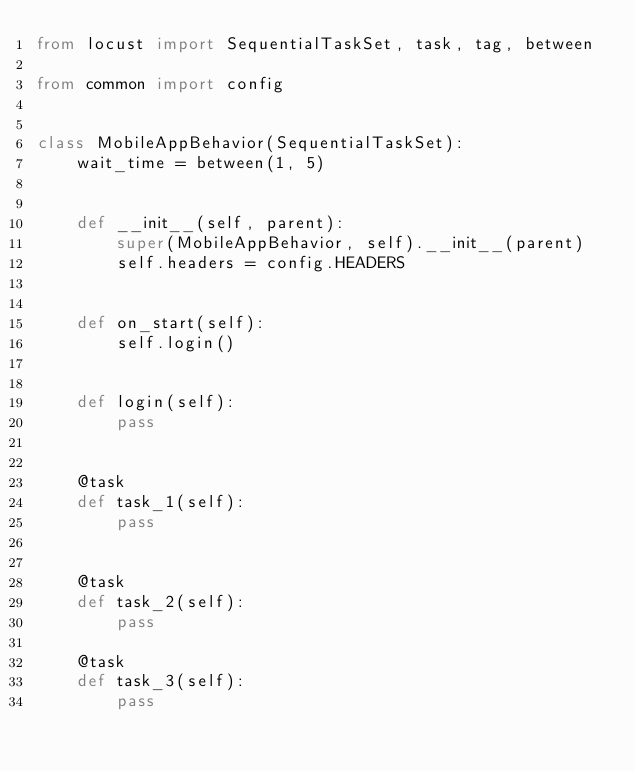<code> <loc_0><loc_0><loc_500><loc_500><_Python_>from locust import SequentialTaskSet, task, tag, between

from common import config


class MobileAppBehavior(SequentialTaskSet):
	wait_time = between(1, 5)


	def __init__(self, parent):
		super(MobileAppBehavior, self).__init__(parent)
		self.headers = config.HEADERS


	def on_start(self):
		self.login()


	def login(self):
		pass


	@task
	def task_1(self):
		pass


	@task
	def task_2(self):
		pass

	@task
	def task_3(self):
		pass</code> 